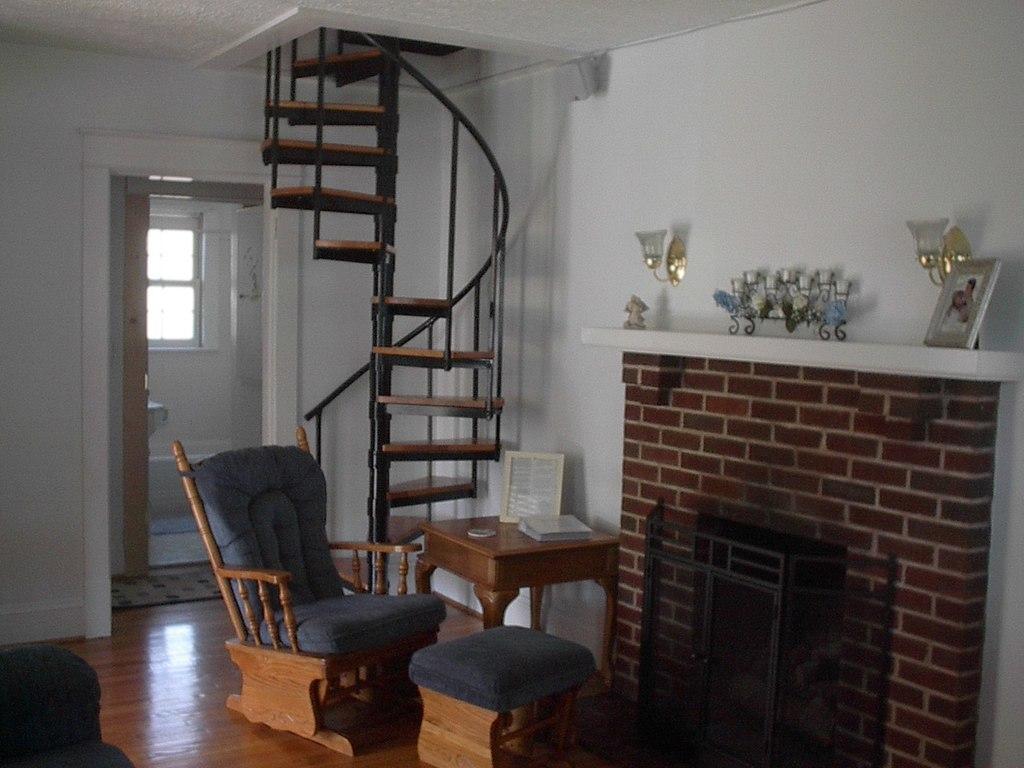Please provide a concise description of this image. In this picture I can see there is a sofa and a stool and there is fire place on to the right side and there is a wall, stairs and a door in the backdrop. 